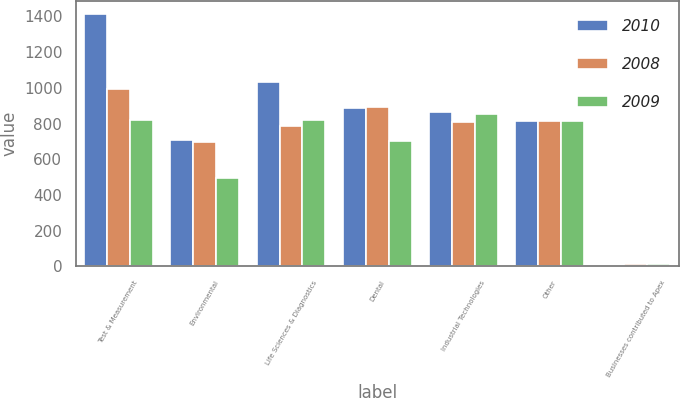Convert chart. <chart><loc_0><loc_0><loc_500><loc_500><stacked_bar_chart><ecel><fcel>Test & Measurement<fcel>Environmental<fcel>Life Sciences & Diagnostics<fcel>Dental<fcel>Industrial Technologies<fcel>Other<fcel>Businesses contributed to Apex<nl><fcel>2010<fcel>1416.6<fcel>709.5<fcel>1031.3<fcel>885.7<fcel>866.2<fcel>813.6<fcel>6.2<nl><fcel>2008<fcel>995.4<fcel>696<fcel>787.1<fcel>894.5<fcel>808.9<fcel>813.6<fcel>13.8<nl><fcel>2009<fcel>818.5<fcel>493.2<fcel>818.3<fcel>703.4<fcel>856.2<fcel>813.6<fcel>14<nl></chart> 